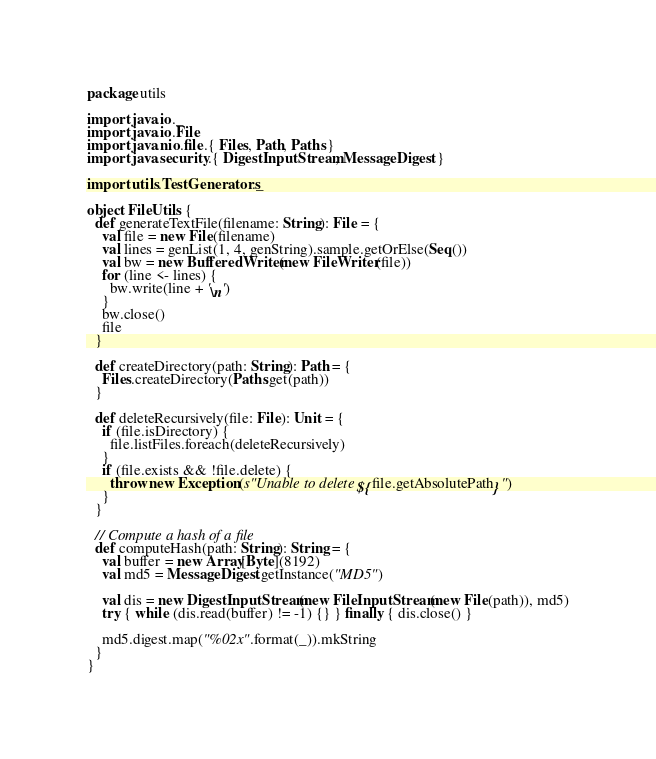<code> <loc_0><loc_0><loc_500><loc_500><_Scala_>package utils

import java.io._
import java.io.File
import java.nio.file.{ Files, Path, Paths }
import java.security.{ DigestInputStream, MessageDigest }

import utils.TestGenerators._

object FileUtils {
  def generateTextFile(filename: String): File = {
    val file = new File(filename)
    val lines = genList(1, 4, genString).sample.getOrElse(Seq())
    val bw = new BufferedWriter(new FileWriter(file))
    for (line <- lines) {
      bw.write(line + '\n')
    }
    bw.close()
    file
  }

  def createDirectory(path: String): Path = {
    Files.createDirectory(Paths.get(path))
  }

  def deleteRecursively(file: File): Unit = {
    if (file.isDirectory) {
      file.listFiles.foreach(deleteRecursively)
    }
    if (file.exists && !file.delete) {
      throw new Exception(s"Unable to delete ${file.getAbsolutePath}")
    }
  }

  // Compute a hash of a file
  def computeHash(path: String): String = {
    val buffer = new Array[Byte](8192)
    val md5 = MessageDigest.getInstance("MD5")

    val dis = new DigestInputStream(new FileInputStream(new File(path)), md5)
    try { while (dis.read(buffer) != -1) {} } finally { dis.close() }

    md5.digest.map("%02x".format(_)).mkString
  }
}</code> 